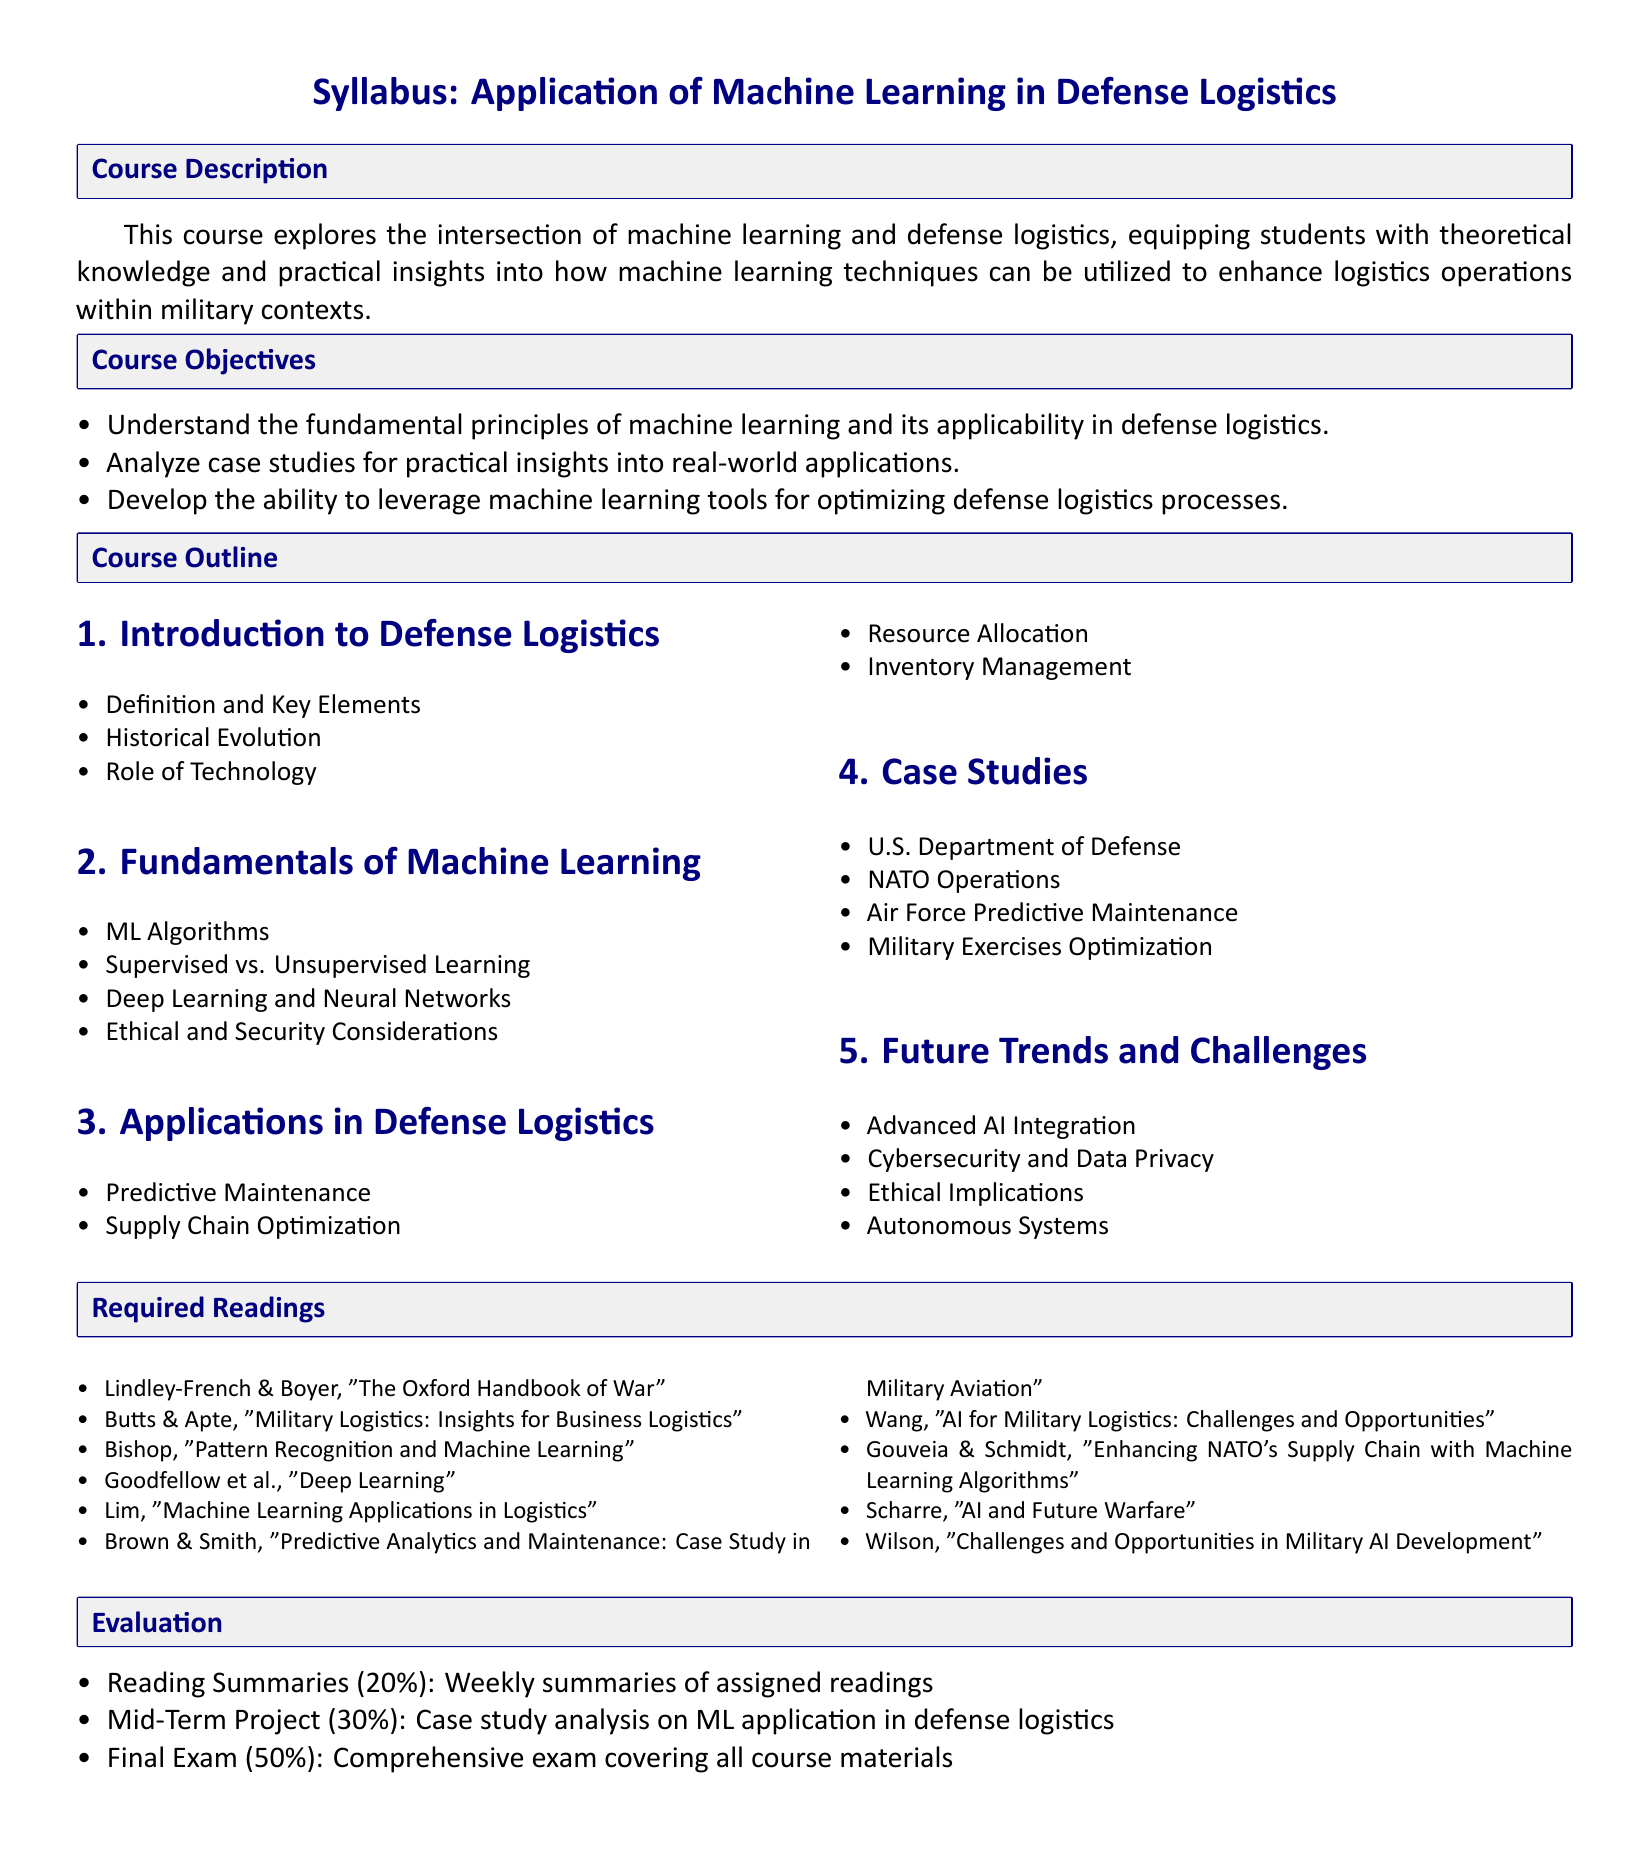What is the course title? The course title is stated at the beginning of the syllabus.
Answer: Application of Machine Learning in Defense Logistics What percentage of the evaluation is based on the final exam? The evaluation section details the weight of each component, including the final exam.
Answer: 50% Who are the authors of the required reading "The Oxford Handbook of War"? The required readings section lists the authors of each book, including this one.
Answer: Lindley-French & Boyer What is one of the applications of machine learning in defense logistics? The applications section mentions various uses of machine learning in defense logistics.
Answer: Predictive Maintenance What is the total percentage for reading summaries in the evaluation? The evaluation section specifies the weight for each component, including reading summaries.
Answer: 20% 